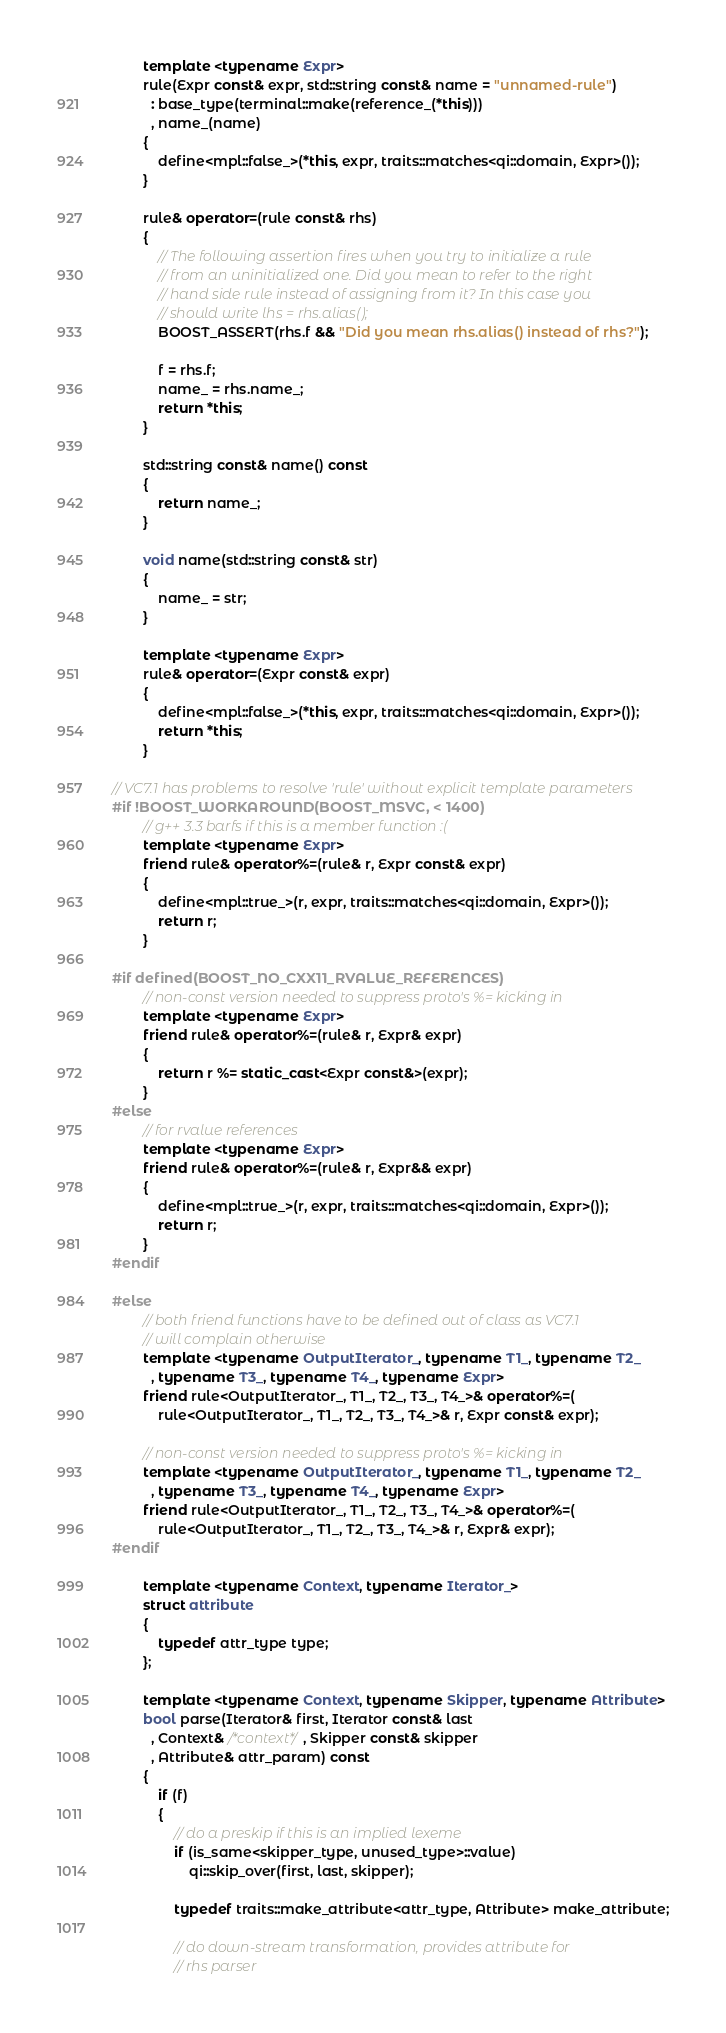Convert code to text. <code><loc_0><loc_0><loc_500><loc_500><_C++_>
        template <typename Expr>
        rule(Expr const& expr, std::string const& name = "unnamed-rule")
          : base_type(terminal::make(reference_(*this)))
          , name_(name)
        {
            define<mpl::false_>(*this, expr, traits::matches<qi::domain, Expr>());
        }

        rule& operator=(rule const& rhs)
        {
            // The following assertion fires when you try to initialize a rule
            // from an uninitialized one. Did you mean to refer to the right
            // hand side rule instead of assigning from it? In this case you
            // should write lhs = rhs.alias();
            BOOST_ASSERT(rhs.f && "Did you mean rhs.alias() instead of rhs?");

            f = rhs.f;
            name_ = rhs.name_;
            return *this;
        }

        std::string const& name() const
        {
            return name_;
        }

        void name(std::string const& str)
        {
            name_ = str;
        }

        template <typename Expr>
        rule& operator=(Expr const& expr)
        {
            define<mpl::false_>(*this, expr, traits::matches<qi::domain, Expr>());
            return *this;
        }

// VC7.1 has problems to resolve 'rule' without explicit template parameters
#if !BOOST_WORKAROUND(BOOST_MSVC, < 1400)
        // g++ 3.3 barfs if this is a member function :(
        template <typename Expr>
        friend rule& operator%=(rule& r, Expr const& expr)
        {
            define<mpl::true_>(r, expr, traits::matches<qi::domain, Expr>());
            return r;
        }

#if defined(BOOST_NO_CXX11_RVALUE_REFERENCES)
        // non-const version needed to suppress proto's %= kicking in
        template <typename Expr>
        friend rule& operator%=(rule& r, Expr& expr)
        {
            return r %= static_cast<Expr const&>(expr);
        }
#else
        // for rvalue references
        template <typename Expr>
        friend rule& operator%=(rule& r, Expr&& expr)
        {
            define<mpl::true_>(r, expr, traits::matches<qi::domain, Expr>());
            return r;
        }
#endif

#else
        // both friend functions have to be defined out of class as VC7.1
        // will complain otherwise
        template <typename OutputIterator_, typename T1_, typename T2_
          , typename T3_, typename T4_, typename Expr>
        friend rule<OutputIterator_, T1_, T2_, T3_, T4_>& operator%=(
            rule<OutputIterator_, T1_, T2_, T3_, T4_>& r, Expr const& expr);

        // non-const version needed to suppress proto's %= kicking in
        template <typename OutputIterator_, typename T1_, typename T2_
          , typename T3_, typename T4_, typename Expr>
        friend rule<OutputIterator_, T1_, T2_, T3_, T4_>& operator%=(
            rule<OutputIterator_, T1_, T2_, T3_, T4_>& r, Expr& expr);
#endif

        template <typename Context, typename Iterator_>
        struct attribute
        {
            typedef attr_type type;
        };

        template <typename Context, typename Skipper, typename Attribute>
        bool parse(Iterator& first, Iterator const& last
          , Context& /*context*/, Skipper const& skipper
          , Attribute& attr_param) const
        {
            if (f)
            {
                // do a preskip if this is an implied lexeme
                if (is_same<skipper_type, unused_type>::value)
                    qi::skip_over(first, last, skipper);

                typedef traits::make_attribute<attr_type, Attribute> make_attribute;

                // do down-stream transformation, provides attribute for
                // rhs parser</code> 